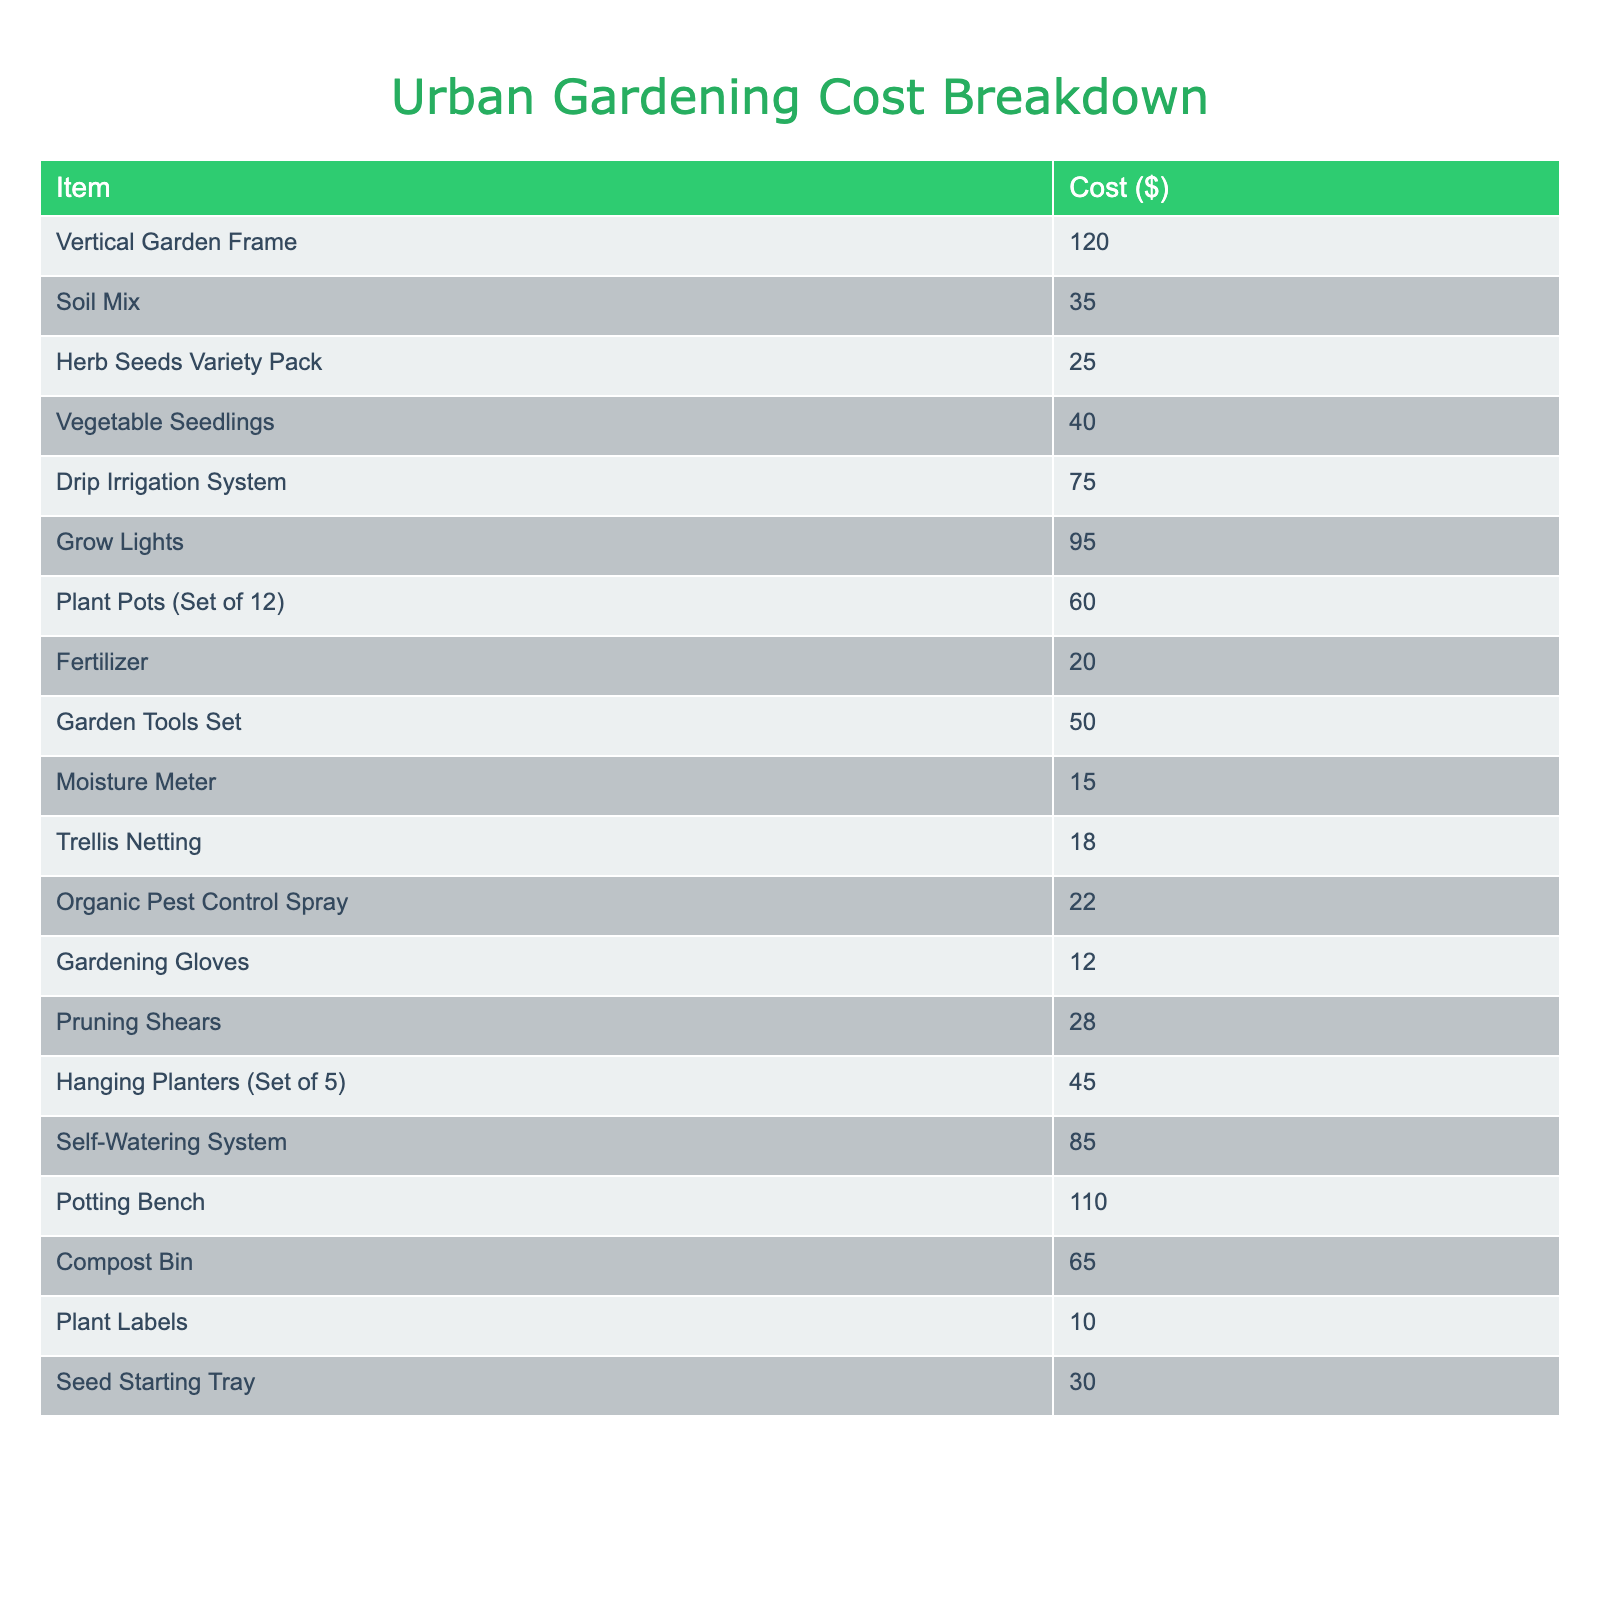What is the cost of the Vertical Garden Frame? The table lists the cost of the Vertical Garden Frame as one of the items. Referring to the "Cost ($)" column, the listed price is 120.
Answer: 120 What are the total costs for soil-related items (Soil Mix, Fertilizer, Compost Bin)? First, we identify the relevant items: Soil Mix (35), Fertilizer (20), and Compost Bin (65). Adding these together: 35 + 20 + 65 = 120.
Answer: 120 Is the cost of Grow Lights more expensive than Drip Irrigation System? The cost of Grow Lights is 95 and the cost of Drip Irrigation System is 75. Since 95 is greater than 75, it confirms Grow Lights are more expensive.
Answer: Yes What is the sum of costs for seeds and planting supplies (Herb Seeds Variety Pack, Vegetable Seedlings, Plant Pots, and Plant Labels)? The relevant items are: Herb Seeds Variety Pack (25), Vegetable Seedlings (40), Plant Pots (60), and Plant Labels (10). Sum these values: 25 + 40 + 60 + 10 = 135.
Answer: 135 Which item has the lowest cost and what is that cost? By examining the "Cost ($)" column, the item with the lowest cost is the Moisture Meter, priced at 15.
Answer: 15 What is the average cost of all the items listed in the table? There are 20 items with a combined cost total of 735. To find the average, we divide the total by the number of items: 735 / 20 = 36.75.
Answer: 36.75 How much would it cost to purchase all the gardening tools (Garden Tools Set, Pruning Shears, and Gardening Gloves) together? The total cost for the gardening tools is: Garden Tools Set (50) + Pruning Shears (28) + Gardening Gloves (12). Adding these gives us: 50 + 28 + 12 = 90.
Answer: 90 Are there more items related to planting than irrigation in the table? We count the items: there are 8 planting-related items (seeds, pots, labels, etc.) and 3 irrigation-related items (Drip Irrigation System, Grow Lights, Self-Watering System). Therefore, there are more planting items.
Answer: Yes What is the difference in cost between the Potting Bench and the Vertical Garden Frame? The cost of the Potting Bench is 110 and the Vertical Garden Frame is 120. The difference is 120 - 110 = 10.
Answer: 10 If I were to buy all the items related to pest control (Organic Pest Control Spray), how much would I spend? The relevant item, Organic Pest Control Spray, costs 22. Since it's the only item mentioned, the total cost for pest control is just 22.
Answer: 22 